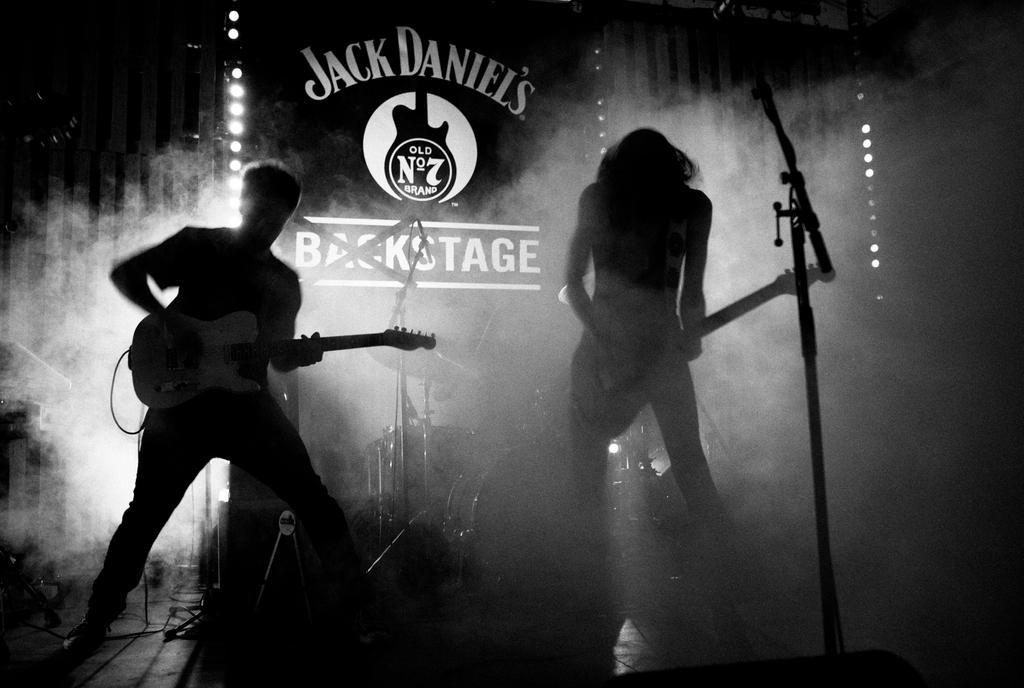In one or two sentences, can you explain what this image depicts? In this image I can see the two people standing and playing the musical instruments. At the back there is a banner,drum set and the smoke. 